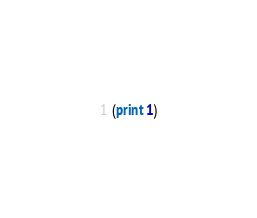<code> <loc_0><loc_0><loc_500><loc_500><_Scheme_>(print 1)</code> 